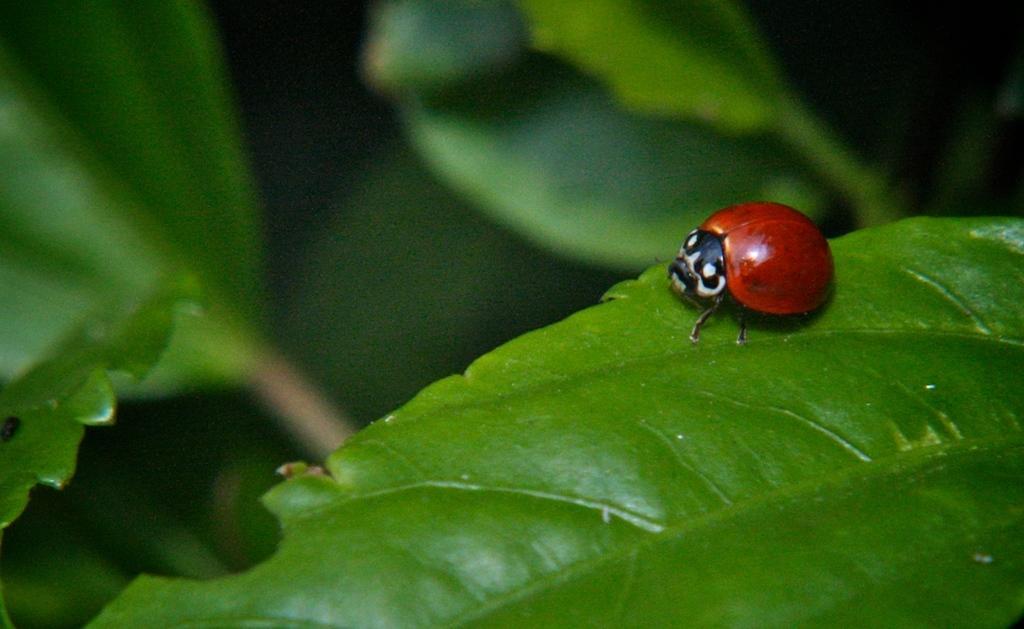Can you describe this image briefly? In this image we can see a bug on the leaf. 